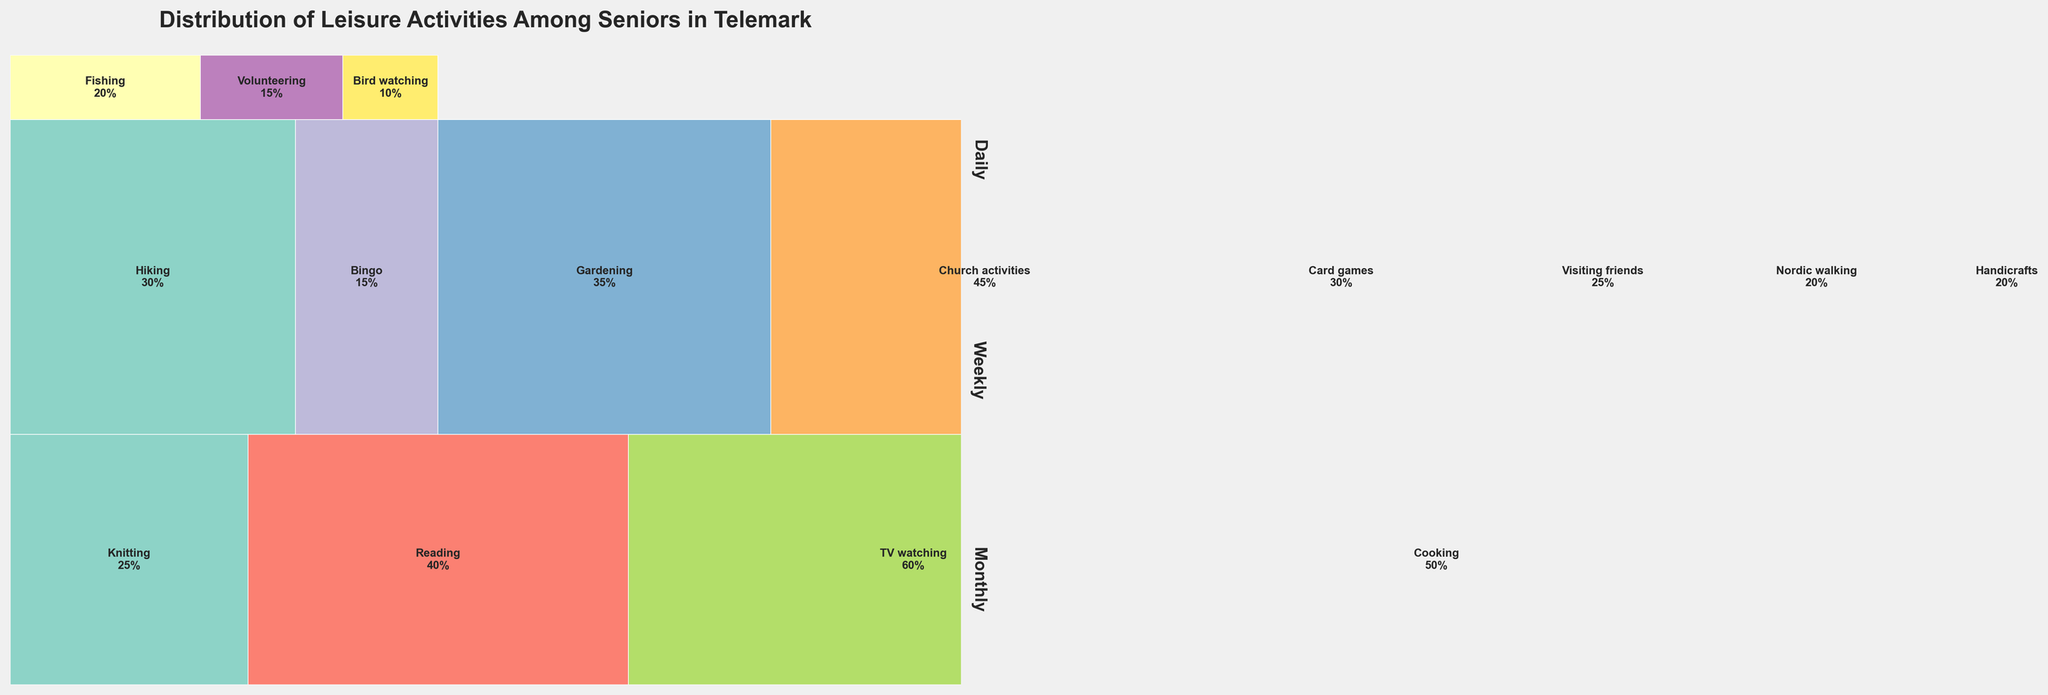What is the title of the mosaic plot? The title of the plot is displayed prominently at the top of the figure.
Answer: Distribution of Leisure Activities Among Seniors in Telemark How many leisure activities are displayed in the mosaic plot? Count the unique activities listed within the plot.
Answer: 15 Which activity has the highest percentage for daily frequency? Identify the activity listed under 'Daily' with the largest size in the mosaic.
Answer: TV watching Which frequency category occupies the largest space in the mosaic plot? Compare the total areas occupied by each frequency (Daily, Weekly, Monthly) and identify the largest.
Answer: Weekly What is the combined percentage of 'Daily' frequencies? Add the percentages of all activities listed under 'Daily'. Sum: 25 (Knitting) + 40 (Reading) + 60 (TV watching) + 50 (Cooking)
Answer: 175% Which weekly activity has the smallest percentage? Within the 'Weekly' category, find the activity with the smallest section in the mosaic.
Answer: Visiting friends Is there an activity listed under all three frequencies? Check if any activity name appears under 'Daily', 'Weekly', and 'Monthly'.
Answer: No How does the percentage of 'Church activities' compare to 'Hiking'? Compare the sizes of the segments for 'Church activities' and 'Hiking' under 'Weekly'.
Answer: Church activities is larger What is the percentage gap between 'Fishing' and 'Volunteering' under 'Monthly'? Subtract the percentage of 'Volunteering' from 'Fishing'. Calculation: 20% (Fishing) - 15% (Volunteering)
Answer: 5% Which daily activity is second most frequent? Among the daily activities, identify the one with the second-largest area.
Answer: Cooking 